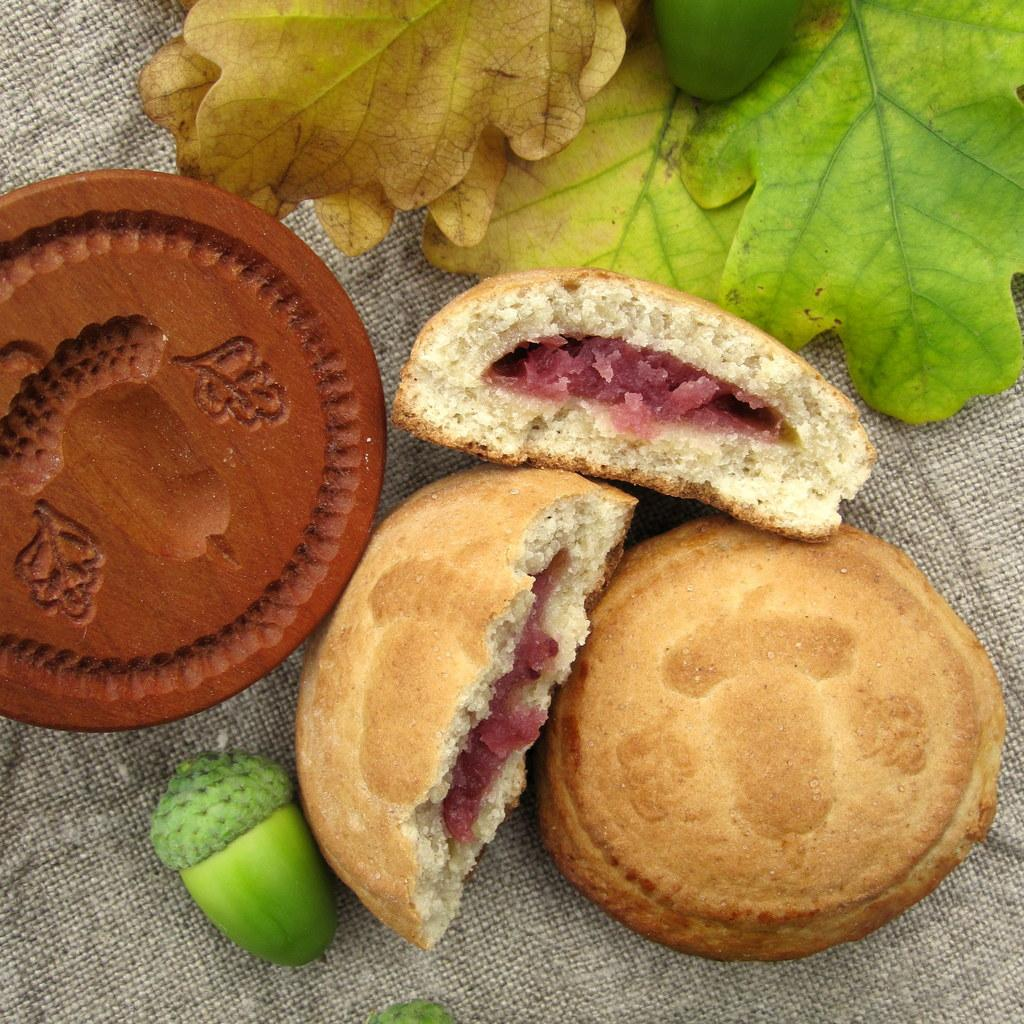What type of items are present in the image? There are eatables in the image. Can you describe the fruit in the image? There is a green color fruit in the image. What colors are the leaves at the top of the image? The leaves at the top of the image are in green and yellow color. What might be present in the background of the image? There might be a cloth or a bag in the background of the image. What type of haircut is the kettle getting in the image? There is no kettle present in the image, and therefore no haircut can be observed. What type of lumber is visible in the image? There is no lumber present in the image. 